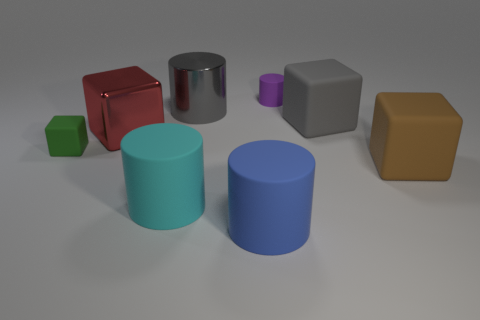There is a rubber block that is behind the shiny block; does it have the same color as the tiny rubber cylinder?
Keep it short and to the point. No. There is a large thing that is the same color as the big shiny cylinder; what is it made of?
Offer a terse response. Rubber. What number of small matte objects are the same color as the large shiny cube?
Make the answer very short. 0. Does the small matte thing that is behind the small green thing have the same shape as the blue object?
Make the answer very short. Yes. Are there fewer gray things in front of the green matte cube than large cylinders that are behind the red cube?
Make the answer very short. Yes. What is the material of the small thing in front of the purple cylinder?
Give a very brief answer. Rubber. What is the size of the matte block that is the same color as the metallic cylinder?
Your answer should be compact. Large. Are there any rubber cylinders of the same size as the brown block?
Give a very brief answer. Yes. There is a large gray matte thing; is it the same shape as the tiny rubber object that is left of the purple rubber cylinder?
Your answer should be compact. Yes. There is a brown rubber object behind the large blue rubber cylinder; is its size the same as the rubber cylinder that is behind the gray block?
Your response must be concise. No. 